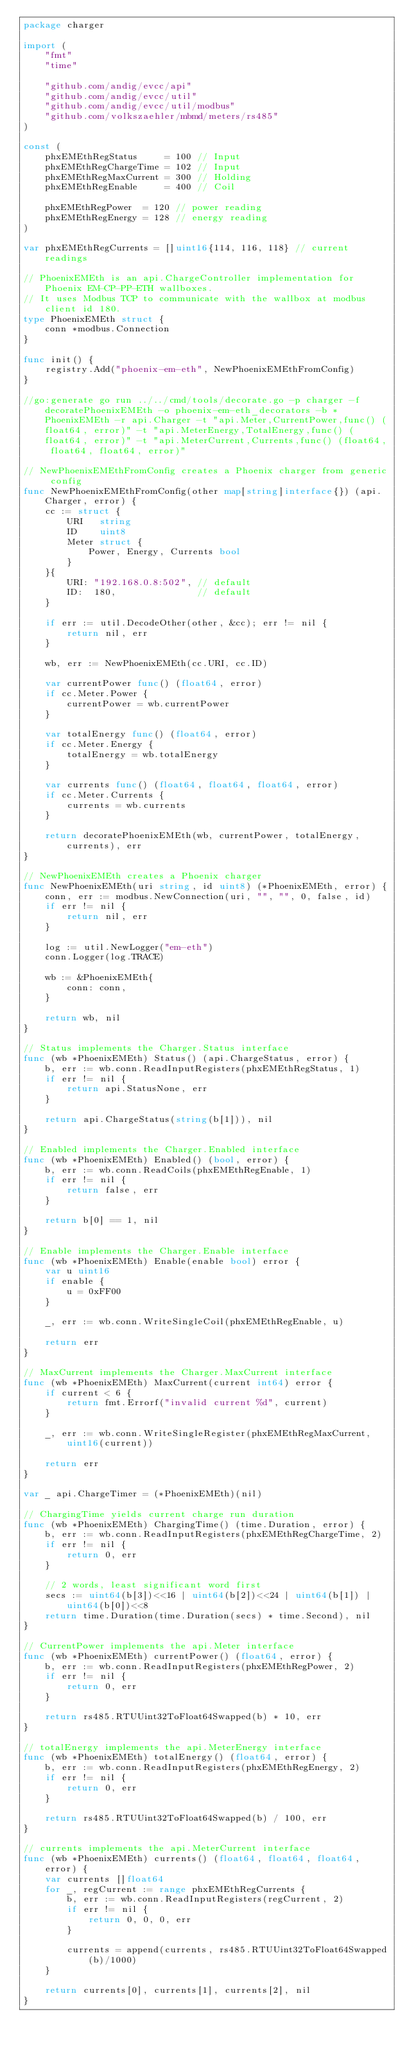<code> <loc_0><loc_0><loc_500><loc_500><_Go_>package charger

import (
	"fmt"
	"time"

	"github.com/andig/evcc/api"
	"github.com/andig/evcc/util"
	"github.com/andig/evcc/util/modbus"
	"github.com/volkszaehler/mbmd/meters/rs485"
)

const (
	phxEMEthRegStatus     = 100 // Input
	phxEMEthRegChargeTime = 102 // Input
	phxEMEthRegMaxCurrent = 300 // Holding
	phxEMEthRegEnable     = 400 // Coil

	phxEMEthRegPower  = 120 // power reading
	phxEMEthRegEnergy = 128 // energy reading
)

var phxEMEthRegCurrents = []uint16{114, 116, 118} // current readings

// PhoenixEMEth is an api.ChargeController implementation for Phoenix EM-CP-PP-ETH wallboxes.
// It uses Modbus TCP to communicate with the wallbox at modbus client id 180.
type PhoenixEMEth struct {
	conn *modbus.Connection
}

func init() {
	registry.Add("phoenix-em-eth", NewPhoenixEMEthFromConfig)
}

//go:generate go run ../../cmd/tools/decorate.go -p charger -f decoratePhoenixEMEth -o phoenix-em-eth_decorators -b *PhoenixEMEth -r api.Charger -t "api.Meter,CurrentPower,func() (float64, error)" -t "api.MeterEnergy,TotalEnergy,func() (float64, error)" -t "api.MeterCurrent,Currents,func() (float64, float64, float64, error)"

// NewPhoenixEMEthFromConfig creates a Phoenix charger from generic config
func NewPhoenixEMEthFromConfig(other map[string]interface{}) (api.Charger, error) {
	cc := struct {
		URI   string
		ID    uint8
		Meter struct {
			Power, Energy, Currents bool
		}
	}{
		URI: "192.168.0.8:502", // default
		ID:  180,               // default
	}

	if err := util.DecodeOther(other, &cc); err != nil {
		return nil, err
	}

	wb, err := NewPhoenixEMEth(cc.URI, cc.ID)

	var currentPower func() (float64, error)
	if cc.Meter.Power {
		currentPower = wb.currentPower
	}

	var totalEnergy func() (float64, error)
	if cc.Meter.Energy {
		totalEnergy = wb.totalEnergy
	}

	var currents func() (float64, float64, float64, error)
	if cc.Meter.Currents {
		currents = wb.currents
	}

	return decoratePhoenixEMEth(wb, currentPower, totalEnergy, currents), err
}

// NewPhoenixEMEth creates a Phoenix charger
func NewPhoenixEMEth(uri string, id uint8) (*PhoenixEMEth, error) {
	conn, err := modbus.NewConnection(uri, "", "", 0, false, id)
	if err != nil {
		return nil, err
	}

	log := util.NewLogger("em-eth")
	conn.Logger(log.TRACE)

	wb := &PhoenixEMEth{
		conn: conn,
	}

	return wb, nil
}

// Status implements the Charger.Status interface
func (wb *PhoenixEMEth) Status() (api.ChargeStatus, error) {
	b, err := wb.conn.ReadInputRegisters(phxEMEthRegStatus, 1)
	if err != nil {
		return api.StatusNone, err
	}

	return api.ChargeStatus(string(b[1])), nil
}

// Enabled implements the Charger.Enabled interface
func (wb *PhoenixEMEth) Enabled() (bool, error) {
	b, err := wb.conn.ReadCoils(phxEMEthRegEnable, 1)
	if err != nil {
		return false, err
	}

	return b[0] == 1, nil
}

// Enable implements the Charger.Enable interface
func (wb *PhoenixEMEth) Enable(enable bool) error {
	var u uint16
	if enable {
		u = 0xFF00
	}

	_, err := wb.conn.WriteSingleCoil(phxEMEthRegEnable, u)

	return err
}

// MaxCurrent implements the Charger.MaxCurrent interface
func (wb *PhoenixEMEth) MaxCurrent(current int64) error {
	if current < 6 {
		return fmt.Errorf("invalid current %d", current)
	}

	_, err := wb.conn.WriteSingleRegister(phxEMEthRegMaxCurrent, uint16(current))

	return err
}

var _ api.ChargeTimer = (*PhoenixEMEth)(nil)

// ChargingTime yields current charge run duration
func (wb *PhoenixEMEth) ChargingTime() (time.Duration, error) {
	b, err := wb.conn.ReadInputRegisters(phxEMEthRegChargeTime, 2)
	if err != nil {
		return 0, err
	}

	// 2 words, least significant word first
	secs := uint64(b[3])<<16 | uint64(b[2])<<24 | uint64(b[1]) | uint64(b[0])<<8
	return time.Duration(time.Duration(secs) * time.Second), nil
}

// CurrentPower implements the api.Meter interface
func (wb *PhoenixEMEth) currentPower() (float64, error) {
	b, err := wb.conn.ReadInputRegisters(phxEMEthRegPower, 2)
	if err != nil {
		return 0, err
	}

	return rs485.RTUUint32ToFloat64Swapped(b) * 10, err
}

// totalEnergy implements the api.MeterEnergy interface
func (wb *PhoenixEMEth) totalEnergy() (float64, error) {
	b, err := wb.conn.ReadInputRegisters(phxEMEthRegEnergy, 2)
	if err != nil {
		return 0, err
	}

	return rs485.RTUUint32ToFloat64Swapped(b) / 100, err
}

// currents implements the api.MeterCurrent interface
func (wb *PhoenixEMEth) currents() (float64, float64, float64, error) {
	var currents []float64
	for _, regCurrent := range phxEMEthRegCurrents {
		b, err := wb.conn.ReadInputRegisters(regCurrent, 2)
		if err != nil {
			return 0, 0, 0, err
		}

		currents = append(currents, rs485.RTUUint32ToFloat64Swapped(b)/1000)
	}

	return currents[0], currents[1], currents[2], nil
}
</code> 